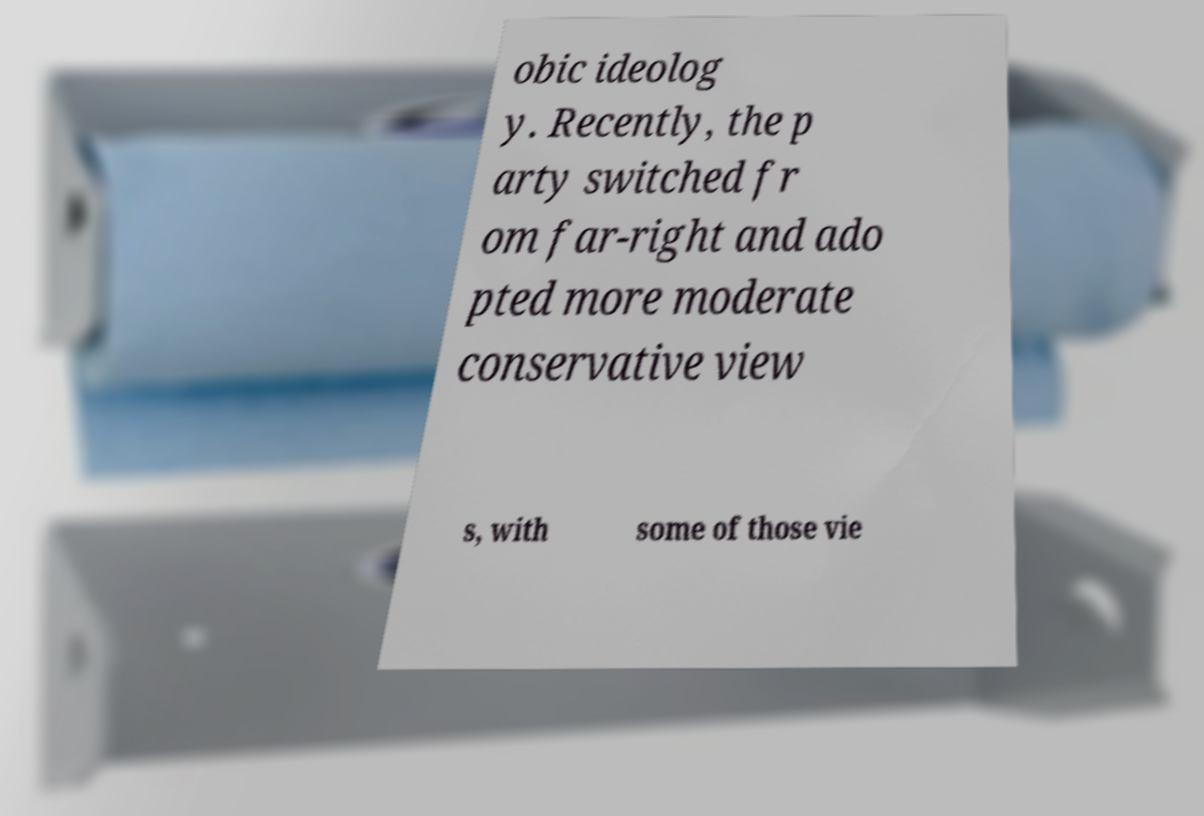Please identify and transcribe the text found in this image. obic ideolog y. Recently, the p arty switched fr om far-right and ado pted more moderate conservative view s, with some of those vie 